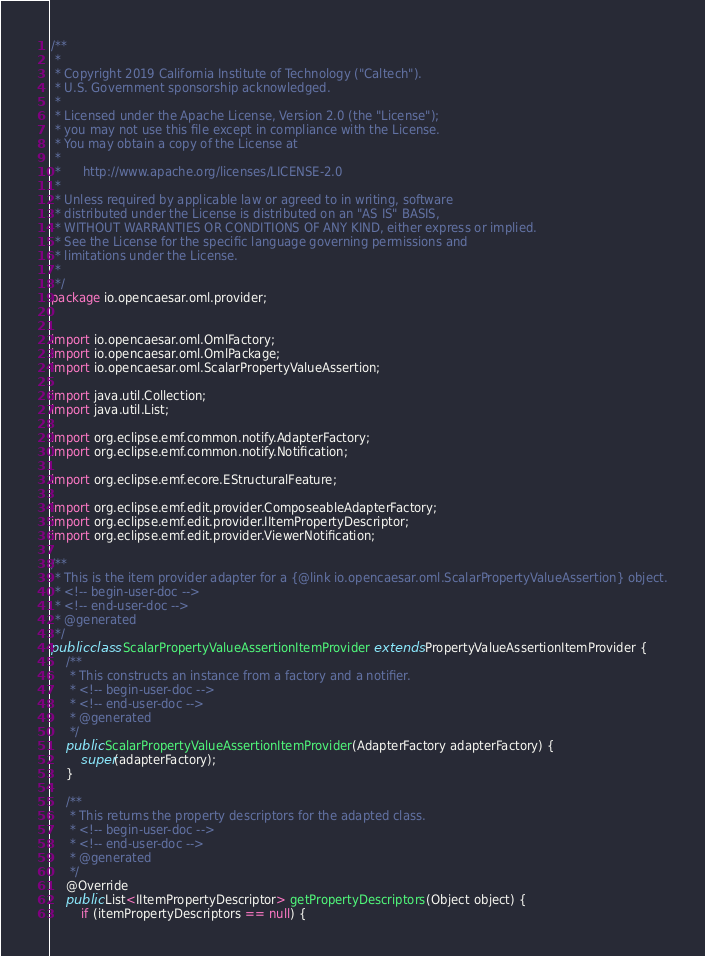<code> <loc_0><loc_0><loc_500><loc_500><_Java_>/**
 * 
 * Copyright 2019 California Institute of Technology ("Caltech").
 * U.S. Government sponsorship acknowledged.
 * 
 * Licensed under the Apache License, Version 2.0 (the "License");
 * you may not use this file except in compliance with the License.
 * You may obtain a copy of the License at
 * 
 *      http://www.apache.org/licenses/LICENSE-2.0
 * 
 * Unless required by applicable law or agreed to in writing, software
 * distributed under the License is distributed on an "AS IS" BASIS,
 * WITHOUT WARRANTIES OR CONDITIONS OF ANY KIND, either express or implied.
 * See the License for the specific language governing permissions and
 * limitations under the License.
 * 
 */
package io.opencaesar.oml.provider;


import io.opencaesar.oml.OmlFactory;
import io.opencaesar.oml.OmlPackage;
import io.opencaesar.oml.ScalarPropertyValueAssertion;

import java.util.Collection;
import java.util.List;

import org.eclipse.emf.common.notify.AdapterFactory;
import org.eclipse.emf.common.notify.Notification;

import org.eclipse.emf.ecore.EStructuralFeature;

import org.eclipse.emf.edit.provider.ComposeableAdapterFactory;
import org.eclipse.emf.edit.provider.IItemPropertyDescriptor;
import org.eclipse.emf.edit.provider.ViewerNotification;

/**
 * This is the item provider adapter for a {@link io.opencaesar.oml.ScalarPropertyValueAssertion} object.
 * <!-- begin-user-doc -->
 * <!-- end-user-doc -->
 * @generated
 */
public class ScalarPropertyValueAssertionItemProvider extends PropertyValueAssertionItemProvider {
	/**
	 * This constructs an instance from a factory and a notifier.
	 * <!-- begin-user-doc -->
	 * <!-- end-user-doc -->
	 * @generated
	 */
	public ScalarPropertyValueAssertionItemProvider(AdapterFactory adapterFactory) {
		super(adapterFactory);
	}

	/**
	 * This returns the property descriptors for the adapted class.
	 * <!-- begin-user-doc -->
	 * <!-- end-user-doc -->
	 * @generated
	 */
	@Override
	public List<IItemPropertyDescriptor> getPropertyDescriptors(Object object) {
		if (itemPropertyDescriptors == null) {</code> 